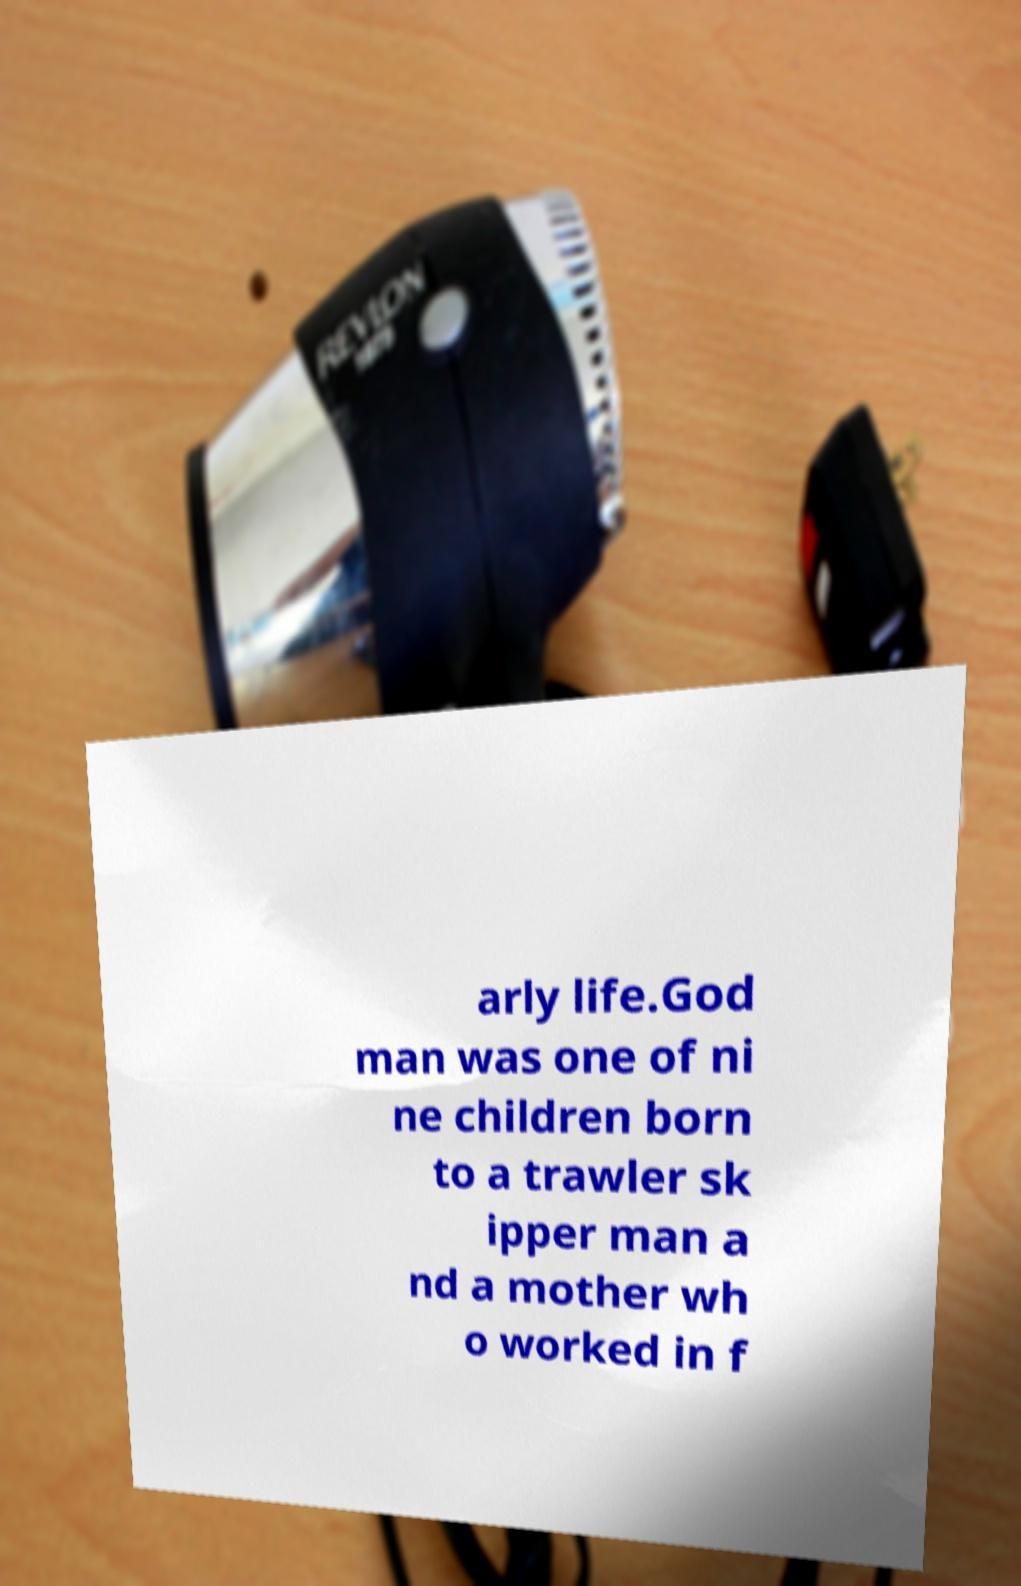Can you accurately transcribe the text from the provided image for me? arly life.God man was one of ni ne children born to a trawler sk ipper man a nd a mother wh o worked in f 